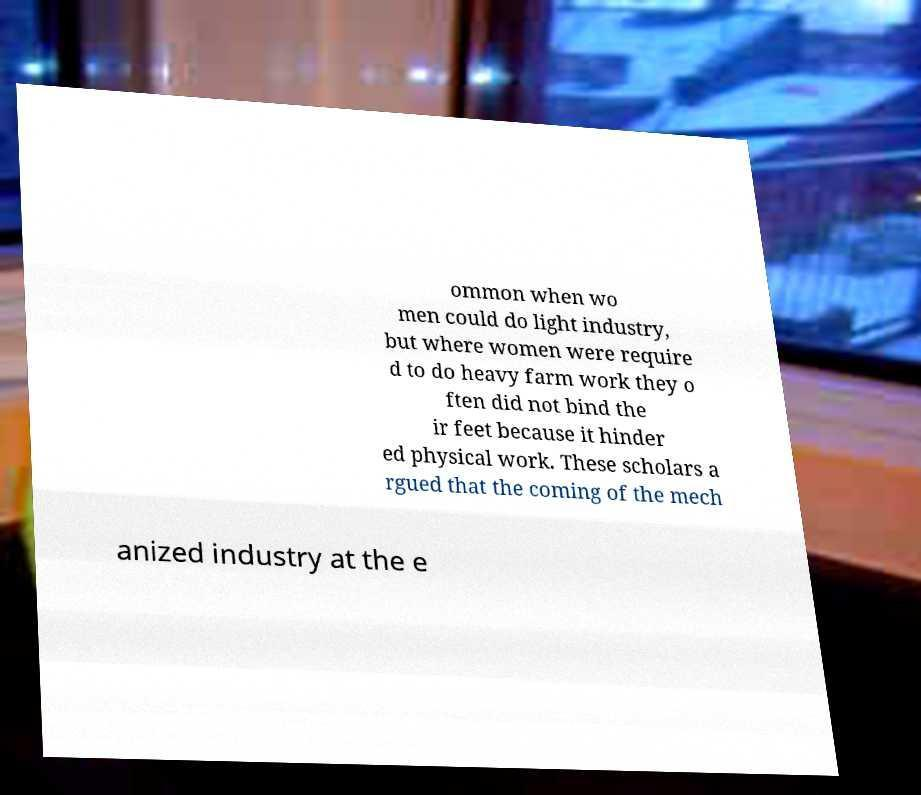For documentation purposes, I need the text within this image transcribed. Could you provide that? ommon when wo men could do light industry, but where women were require d to do heavy farm work they o ften did not bind the ir feet because it hinder ed physical work. These scholars a rgued that the coming of the mech anized industry at the e 